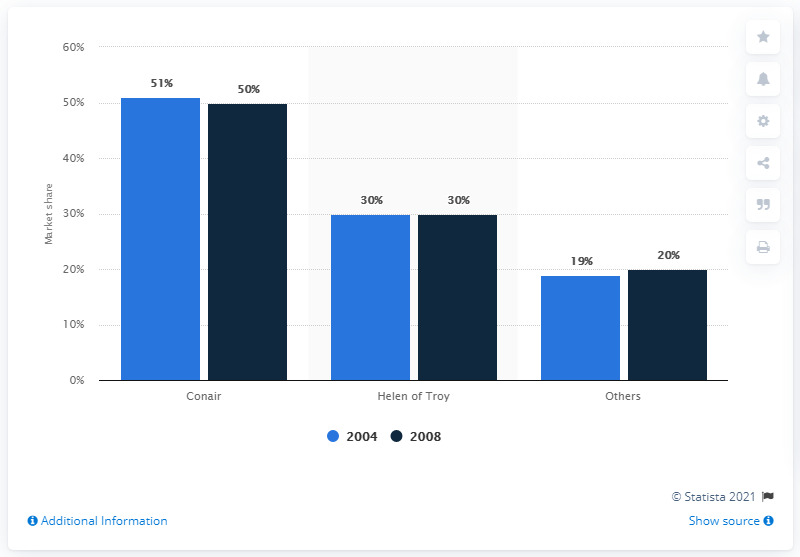Give some essential details in this illustration. According to a source, Conair's hair styling iron market share in 2008 was approximately 50%. 